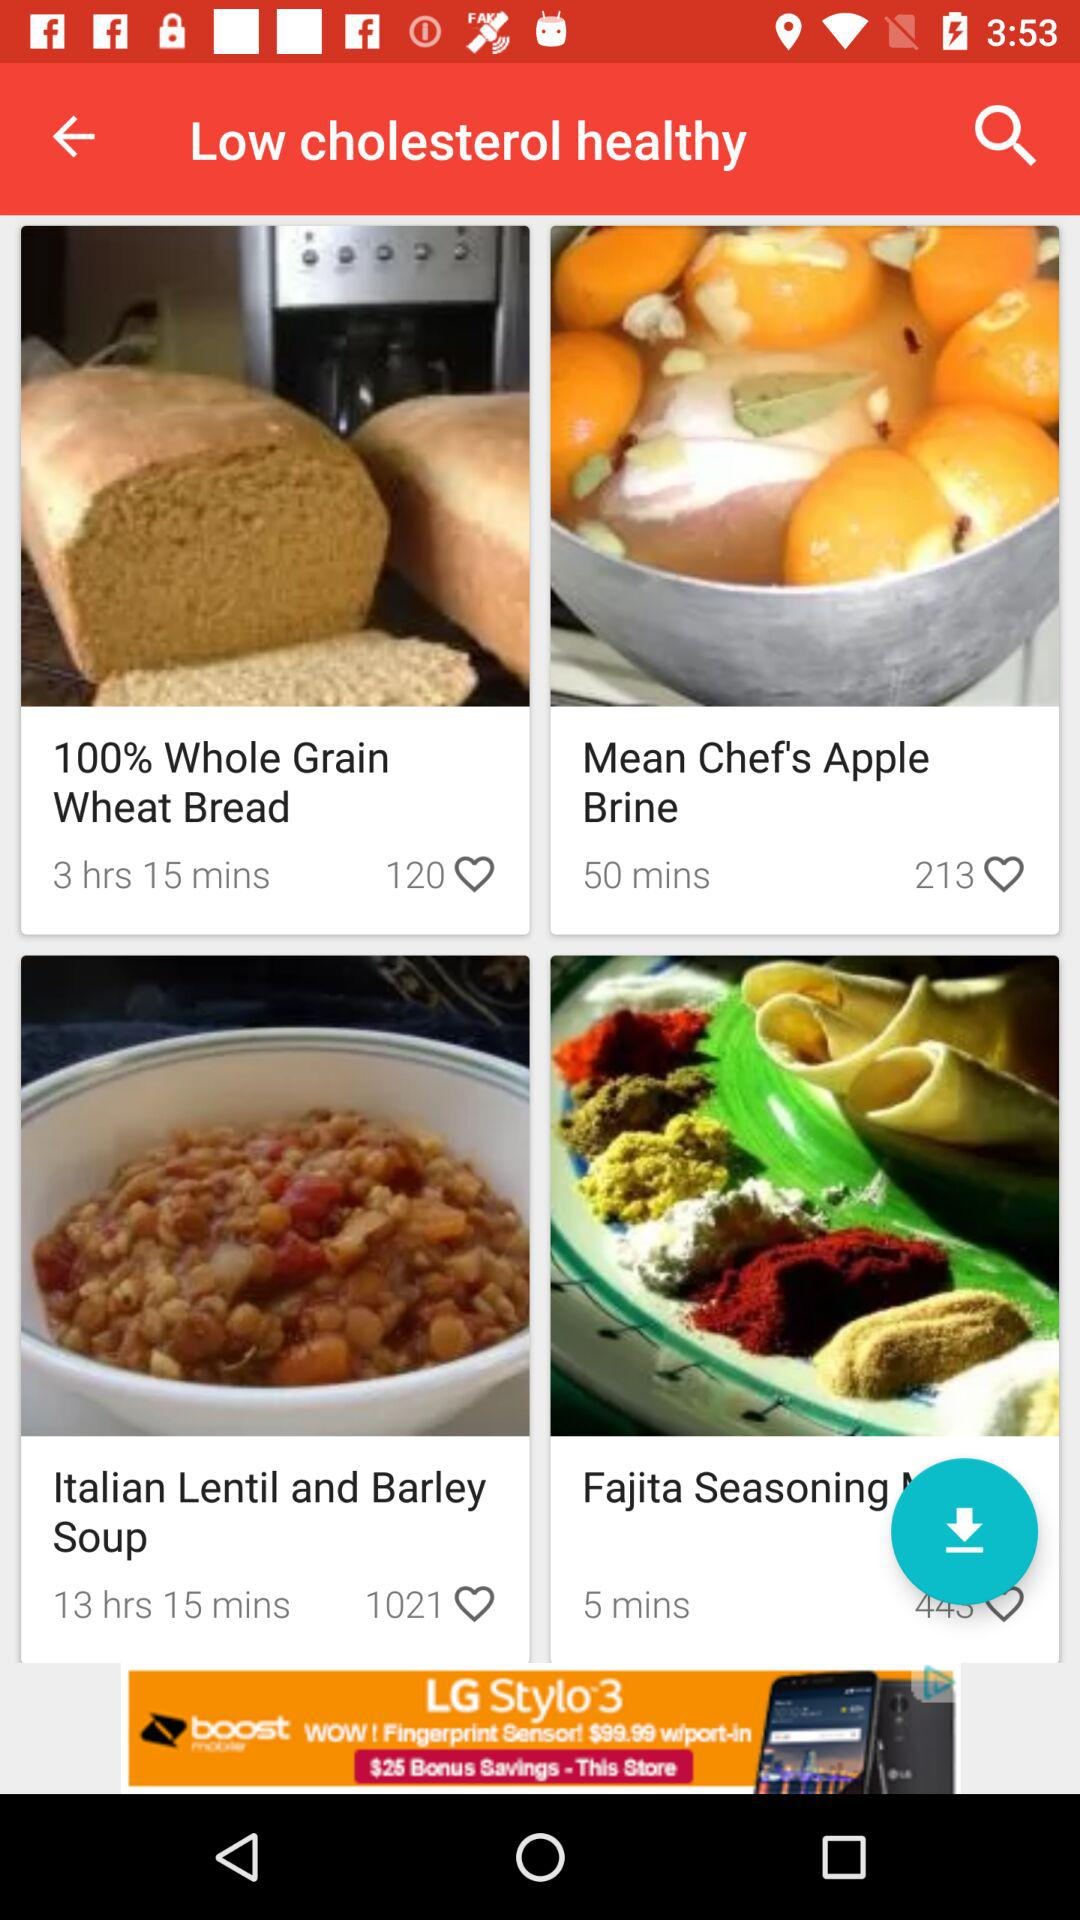What is the number of likes of "Apple Brine"? The number of likes is 213. 